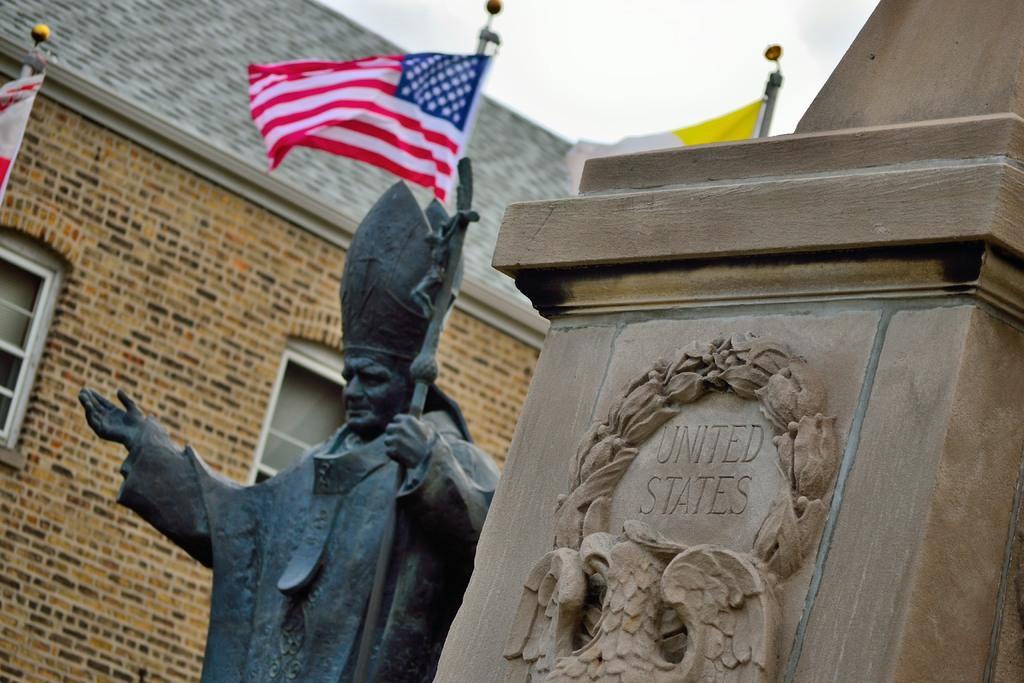Could you give a brief overview of what you see in this image? This image is taken outdoors. In the middle of the image there is a statue. In the background there is a building with a wall, windows and a roof and there are three flags. At the top of the image there is a sky with clouds. On the right side of the image there is a stone with carvings and a text on it. 